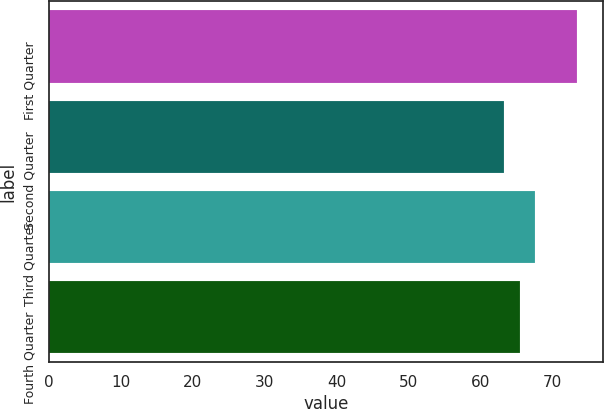Convert chart. <chart><loc_0><loc_0><loc_500><loc_500><bar_chart><fcel>First Quarter<fcel>Second Quarter<fcel>Third Quarter<fcel>Fourth Quarter<nl><fcel>73.43<fcel>63.22<fcel>67.57<fcel>65.44<nl></chart> 